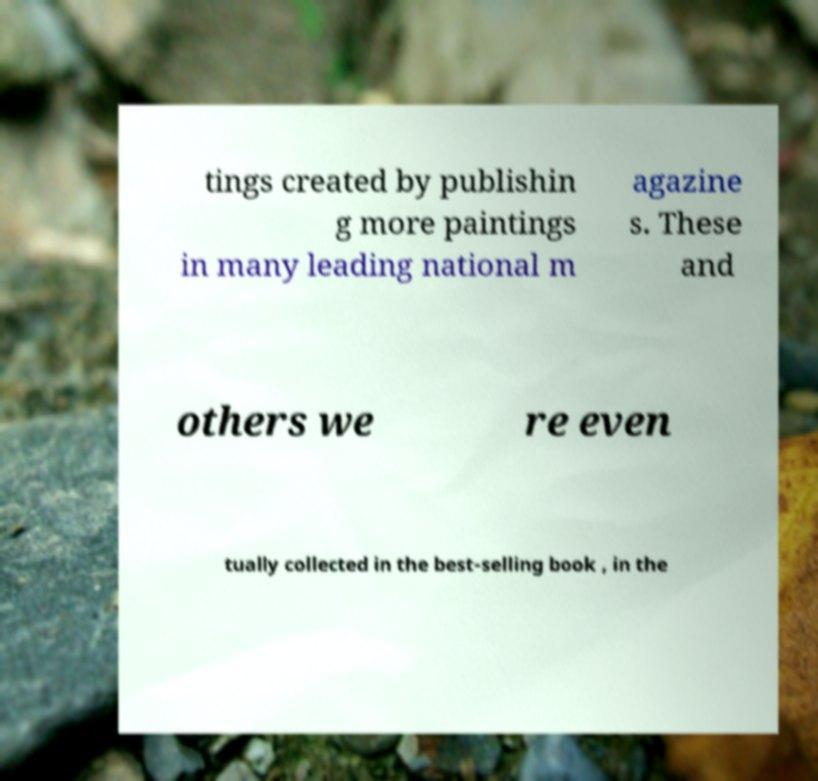Can you read and provide the text displayed in the image?This photo seems to have some interesting text. Can you extract and type it out for me? tings created by publishin g more paintings in many leading national m agazine s. These and others we re even tually collected in the best-selling book , in the 